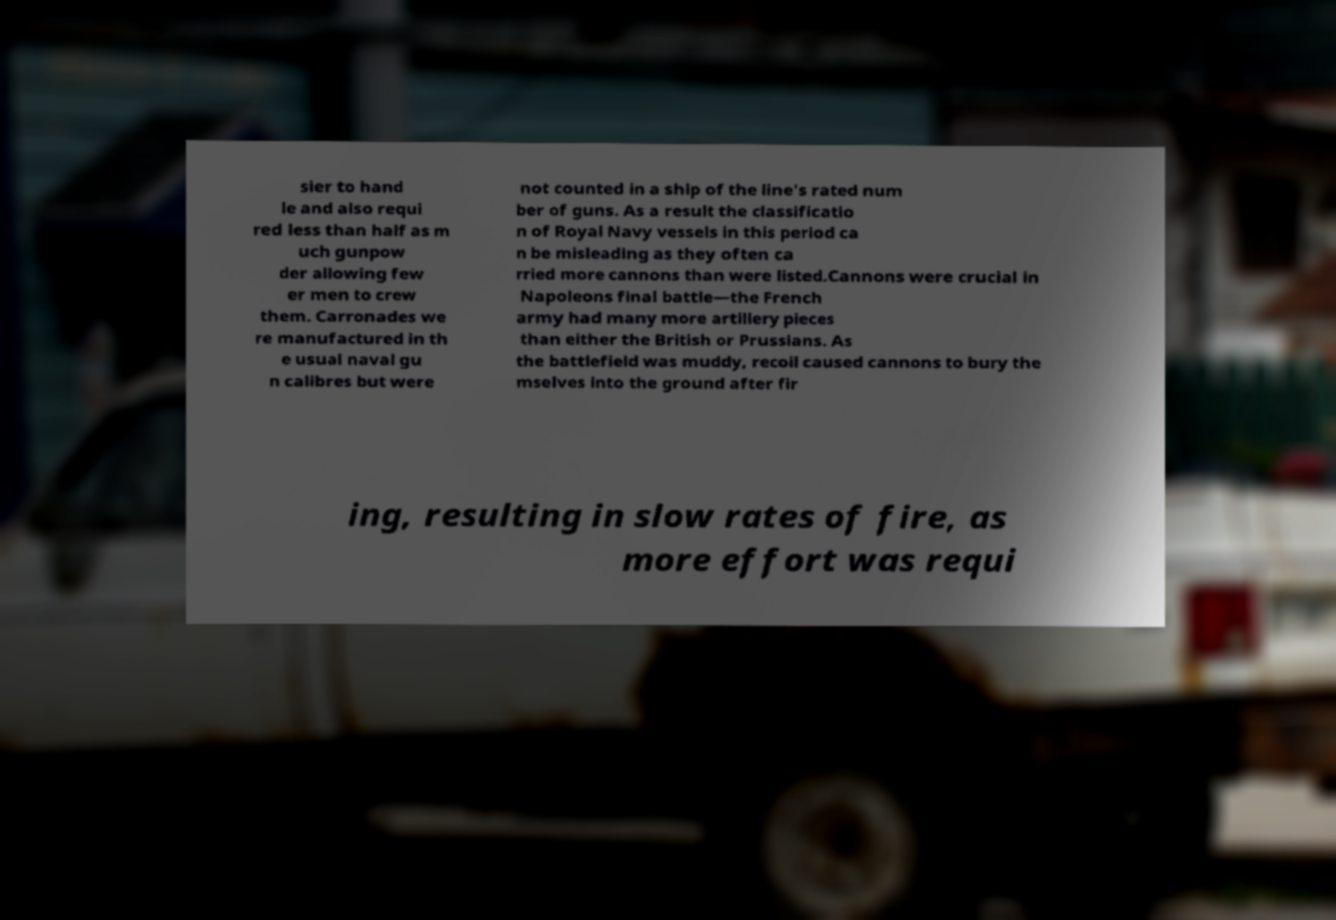Can you accurately transcribe the text from the provided image for me? sier to hand le and also requi red less than half as m uch gunpow der allowing few er men to crew them. Carronades we re manufactured in th e usual naval gu n calibres but were not counted in a ship of the line's rated num ber of guns. As a result the classificatio n of Royal Navy vessels in this period ca n be misleading as they often ca rried more cannons than were listed.Cannons were crucial in Napoleons final battle—the French army had many more artillery pieces than either the British or Prussians. As the battlefield was muddy, recoil caused cannons to bury the mselves into the ground after fir ing, resulting in slow rates of fire, as more effort was requi 